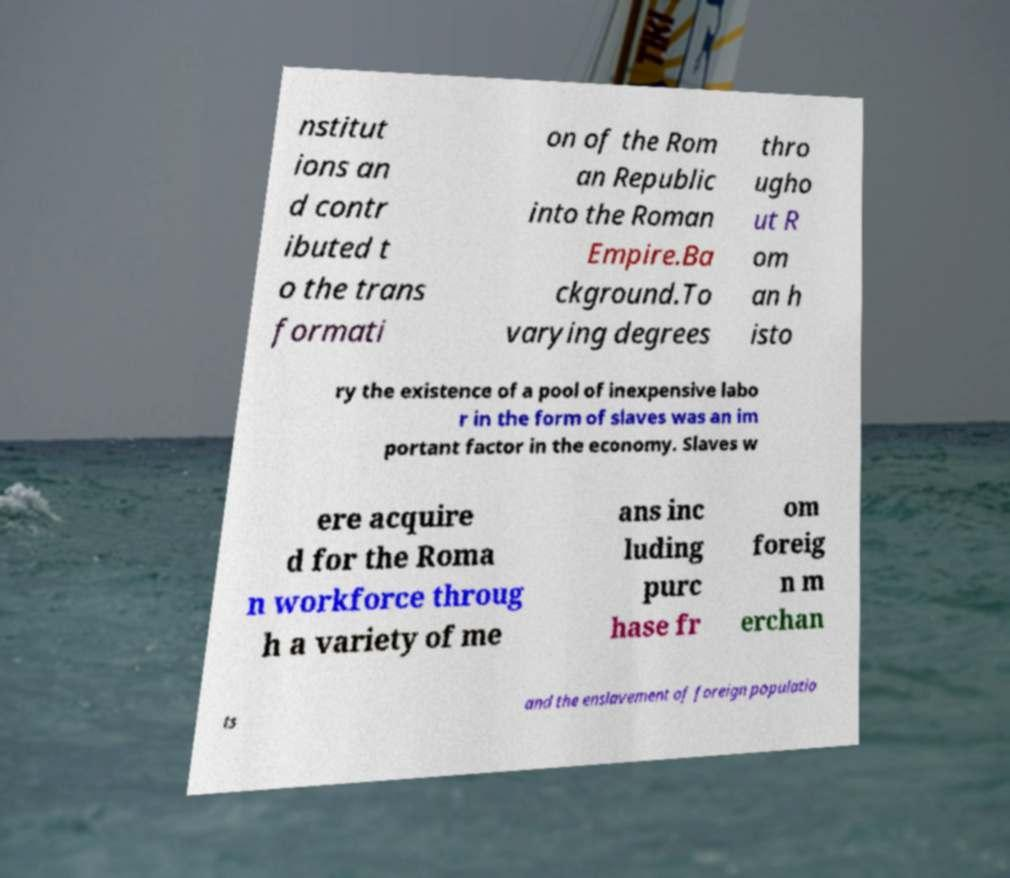Please identify and transcribe the text found in this image. nstitut ions an d contr ibuted t o the trans formati on of the Rom an Republic into the Roman Empire.Ba ckground.To varying degrees thro ugho ut R om an h isto ry the existence of a pool of inexpensive labo r in the form of slaves was an im portant factor in the economy. Slaves w ere acquire d for the Roma n workforce throug h a variety of me ans inc luding purc hase fr om foreig n m erchan ts and the enslavement of foreign populatio 